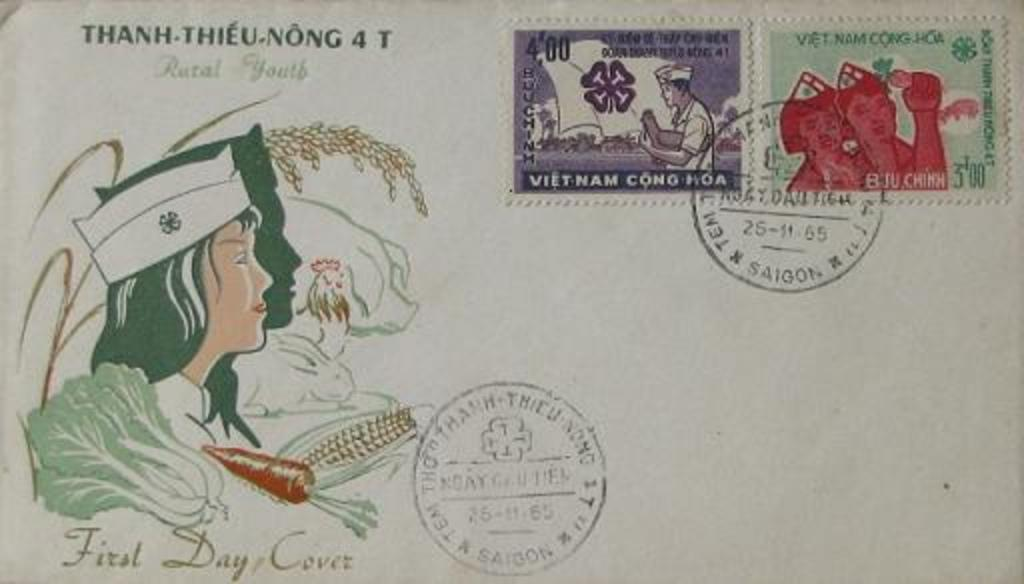Provide a one-sentence caption for the provided image. A postcard with the phrase first day cover in the left hand corner. 